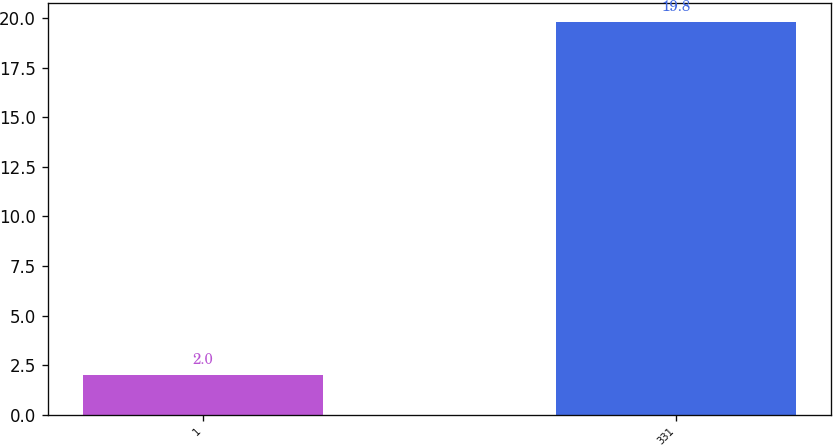Convert chart. <chart><loc_0><loc_0><loc_500><loc_500><bar_chart><fcel>1<fcel>331<nl><fcel>2<fcel>19.8<nl></chart> 